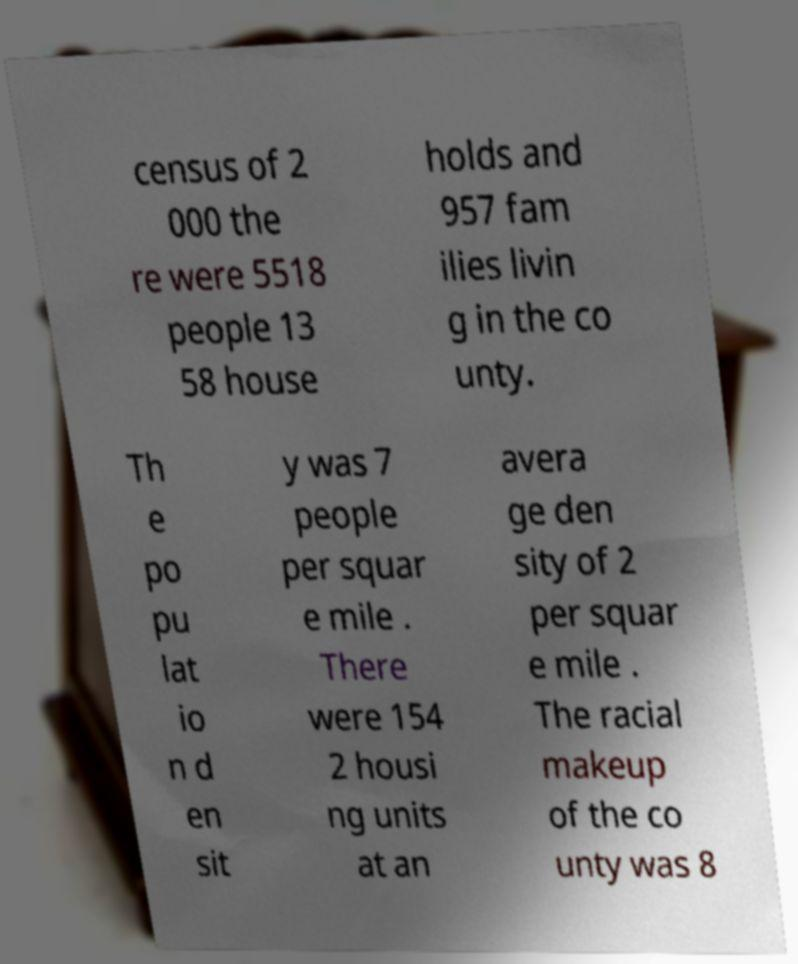Could you extract and type out the text from this image? census of 2 000 the re were 5518 people 13 58 house holds and 957 fam ilies livin g in the co unty. Th e po pu lat io n d en sit y was 7 people per squar e mile . There were 154 2 housi ng units at an avera ge den sity of 2 per squar e mile . The racial makeup of the co unty was 8 